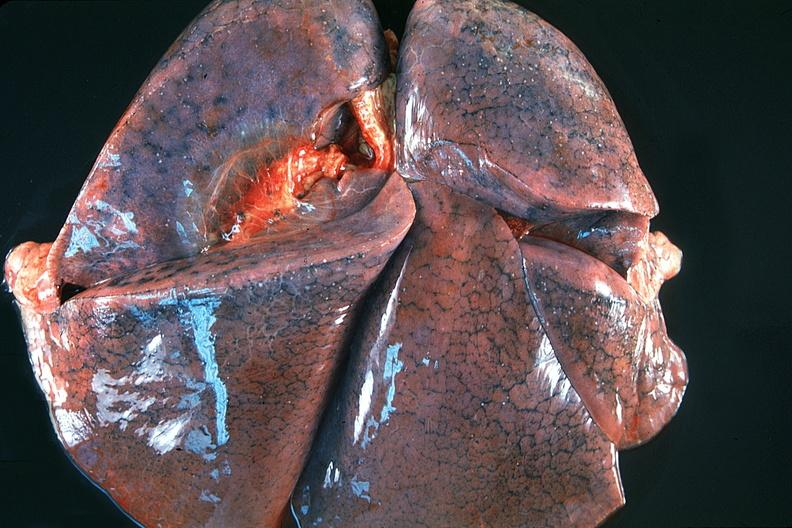what does this image show?
Answer the question using a single word or phrase. Normal lung 